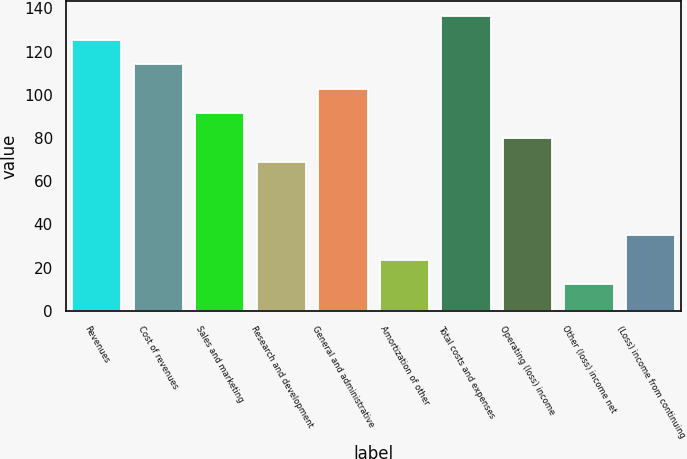Convert chart to OTSL. <chart><loc_0><loc_0><loc_500><loc_500><bar_chart><fcel>Revenues<fcel>Cost of revenues<fcel>Sales and marketing<fcel>Research and development<fcel>General and administrative<fcel>Amortization of other<fcel>Total costs and expenses<fcel>Operating (loss) income<fcel>Other (loss) income net<fcel>(Loss) income from continuing<nl><fcel>125.3<fcel>114<fcel>91.4<fcel>68.8<fcel>102.7<fcel>23.6<fcel>136.6<fcel>80.1<fcel>12.3<fcel>34.9<nl></chart> 